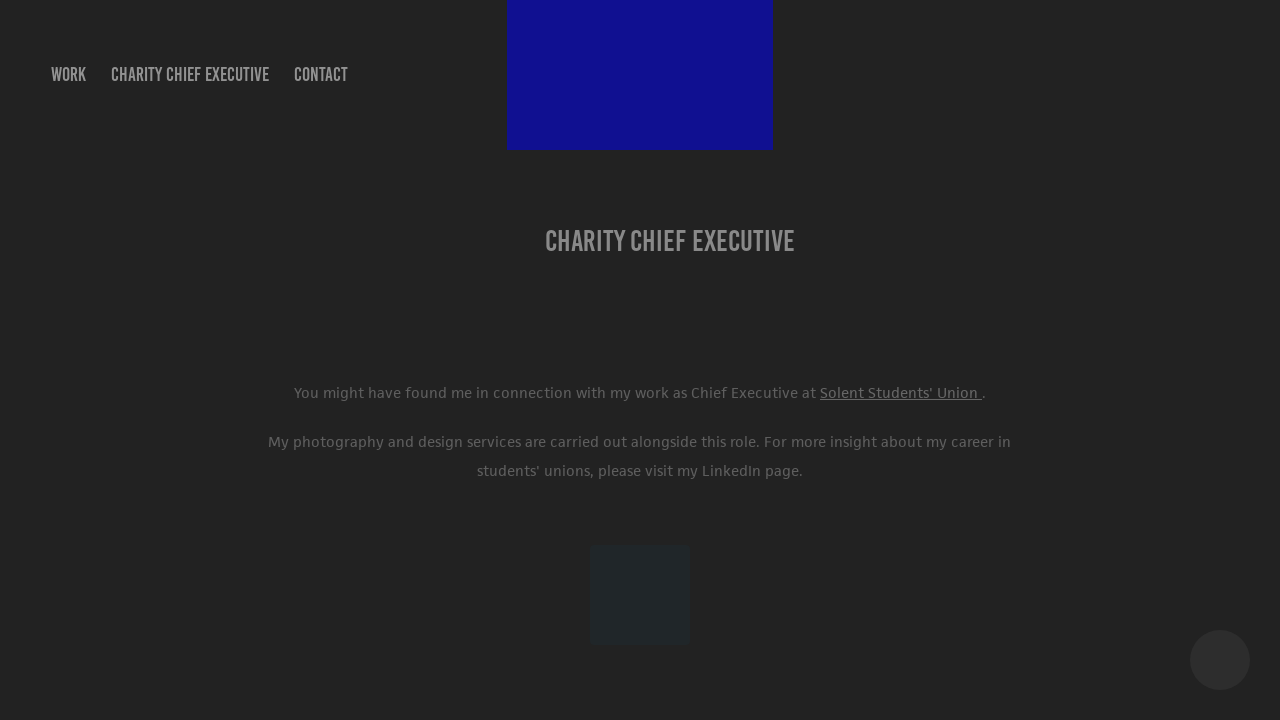What kind of audience do you think this webpage is intended for? This webpage is likely intended for stakeholders involved in charity work, potential employers or collaborators, and individuals interested in the professional life of the website's owner. It could also appeal to those looking into the interplay between leadership roles and creative pursuits. How might the content of the page influence its intended audience? The content could position the site's owner as a committed and versatile professional, appealing to potential employers or partners who value diverse skills. The mention of a LinkedIn page enhances credibility and offers a pathway for deeper engagement or networking. Could the color scheme and layout design affect visitor perceptions too? Absolutely. The use of a dark color scheme with minimalistic design might convey professionalism and seriousness. It could focus visitor attention on the textual content, prioritizing the message over visual elements, which is often appropriate for professional and academic audiences. 